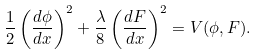Convert formula to latex. <formula><loc_0><loc_0><loc_500><loc_500>\frac { 1 } { 2 } \left ( \frac { d \phi } { d x } \right ) ^ { 2 } + \frac { \lambda } { 8 } \left ( \frac { d F } { d x } \right ) ^ { 2 } = V ( \phi , F ) .</formula> 